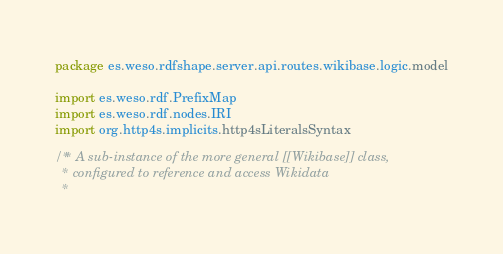Convert code to text. <code><loc_0><loc_0><loc_500><loc_500><_Scala_>package es.weso.rdfshape.server.api.routes.wikibase.logic.model

import es.weso.rdf.PrefixMap
import es.weso.rdf.nodes.IRI
import org.http4s.implicits.http4sLiteralsSyntax

/** A sub-instance of the more general [[Wikibase]] class,
  * configured to reference and access Wikidata
  *</code> 